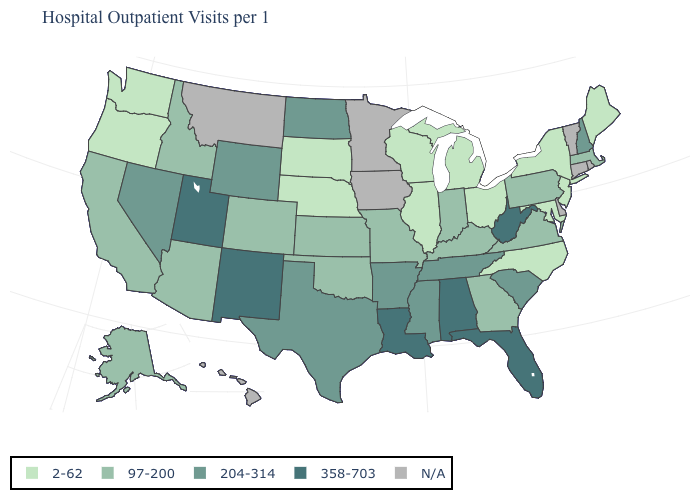What is the value of Delaware?
Keep it brief. N/A. Name the states that have a value in the range 97-200?
Short answer required. Alaska, Arizona, California, Colorado, Georgia, Idaho, Indiana, Kansas, Kentucky, Massachusetts, Missouri, Oklahoma, Pennsylvania, Virginia. What is the value of Montana?
Be succinct. N/A. What is the value of Oklahoma?
Write a very short answer. 97-200. Among the states that border Delaware , which have the highest value?
Give a very brief answer. Pennsylvania. What is the value of Maine?
Concise answer only. 2-62. Name the states that have a value in the range 2-62?
Write a very short answer. Illinois, Maine, Maryland, Michigan, Nebraska, New Jersey, New York, North Carolina, Ohio, Oregon, South Dakota, Washington, Wisconsin. Name the states that have a value in the range 358-703?
Be succinct. Alabama, Florida, Louisiana, New Mexico, Utah, West Virginia. What is the value of Arizona?
Quick response, please. 97-200. Name the states that have a value in the range 97-200?
Keep it brief. Alaska, Arizona, California, Colorado, Georgia, Idaho, Indiana, Kansas, Kentucky, Massachusetts, Missouri, Oklahoma, Pennsylvania, Virginia. Name the states that have a value in the range N/A?
Be succinct. Connecticut, Delaware, Hawaii, Iowa, Minnesota, Montana, Rhode Island, Vermont. Name the states that have a value in the range 97-200?
Concise answer only. Alaska, Arizona, California, Colorado, Georgia, Idaho, Indiana, Kansas, Kentucky, Massachusetts, Missouri, Oklahoma, Pennsylvania, Virginia. Name the states that have a value in the range N/A?
Keep it brief. Connecticut, Delaware, Hawaii, Iowa, Minnesota, Montana, Rhode Island, Vermont. Name the states that have a value in the range 97-200?
Write a very short answer. Alaska, Arizona, California, Colorado, Georgia, Idaho, Indiana, Kansas, Kentucky, Massachusetts, Missouri, Oklahoma, Pennsylvania, Virginia. 